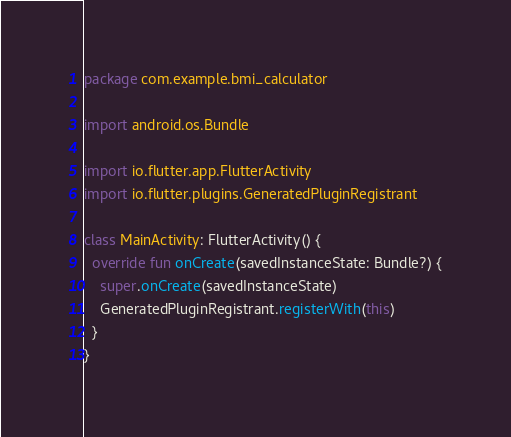<code> <loc_0><loc_0><loc_500><loc_500><_Kotlin_>package com.example.bmi_calculator

import android.os.Bundle

import io.flutter.app.FlutterActivity
import io.flutter.plugins.GeneratedPluginRegistrant

class MainActivity: FlutterActivity() {
  override fun onCreate(savedInstanceState: Bundle?) {
    super.onCreate(savedInstanceState)
    GeneratedPluginRegistrant.registerWith(this)
  }
}
</code> 